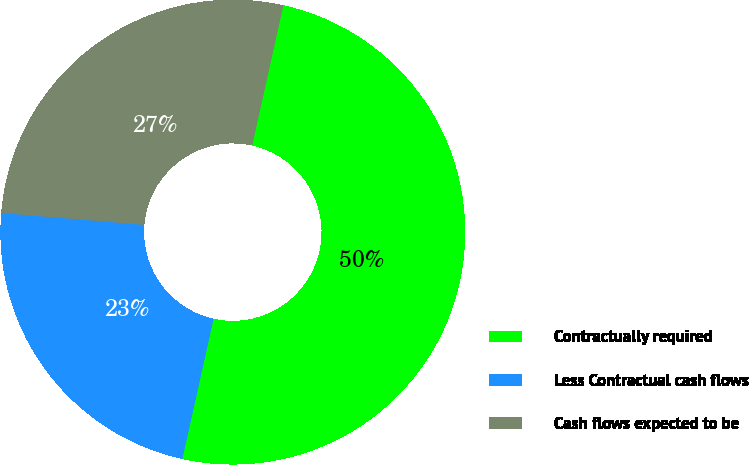Convert chart. <chart><loc_0><loc_0><loc_500><loc_500><pie_chart><fcel>Contractually required<fcel>Less Contractual cash flows<fcel>Cash flows expected to be<nl><fcel>50.0%<fcel>22.83%<fcel>27.17%<nl></chart> 